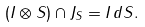<formula> <loc_0><loc_0><loc_500><loc_500>( I \otimes S ) \cap J _ { S } = I \, d S .</formula> 